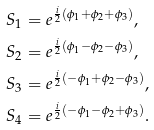Convert formula to latex. <formula><loc_0><loc_0><loc_500><loc_500>& S _ { 1 } = e ^ { \frac { i } { 2 } ( \phi _ { 1 } + \phi _ { 2 } + \phi _ { 3 } ) } , \\ & S _ { 2 } = e ^ { \frac { i } { 2 } ( \phi _ { 1 } - \phi _ { 2 } - \phi _ { 3 } ) } , \\ & S _ { 3 } = e ^ { \frac { i } { 2 } ( - \phi _ { 1 } + \phi _ { 2 } - \phi _ { 3 } ) } , \\ & S _ { 4 } = e ^ { \frac { i } { 2 } ( - \phi _ { 1 } - \phi _ { 2 } + \phi _ { 3 } ) } .</formula> 